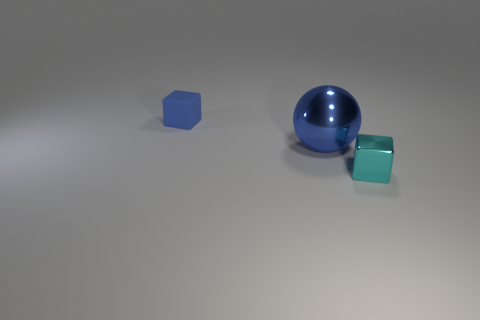Are there any other things that are made of the same material as the small blue object?
Offer a terse response. No. Are there any other things that are the same size as the cyan object?
Keep it short and to the point. Yes. There is a blue metal sphere; what number of large metal balls are to the left of it?
Your answer should be very brief. 0. The blue thing that is behind the large blue metallic object to the left of the cyan object is what shape?
Offer a terse response. Cube. Are there any other things that are the same shape as the blue metal object?
Offer a terse response. No. Is the number of big blue objects to the right of the big blue sphere greater than the number of blue matte cubes?
Provide a succinct answer. No. How many tiny blue matte blocks are in front of the tiny cube in front of the blue cube?
Your response must be concise. 0. There is a blue object on the left side of the blue thing that is in front of the object behind the large shiny ball; what is its shape?
Provide a succinct answer. Cube. How big is the cyan block?
Your response must be concise. Small. Is there a cyan object that has the same material as the blue ball?
Give a very brief answer. Yes. 